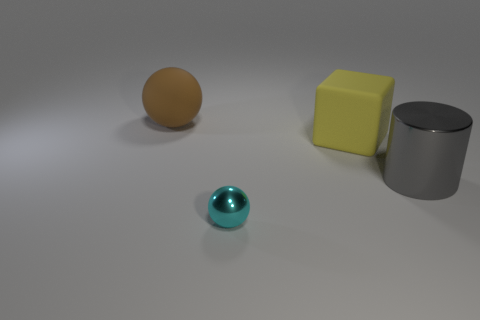Is there anything else that is the same shape as the gray thing?
Offer a terse response. No. Are there any other things that are the same size as the cyan shiny thing?
Your response must be concise. No. What number of things are either large matte objects that are in front of the brown object or things in front of the yellow matte object?
Ensure brevity in your answer.  3. What number of other objects are the same color as the metal ball?
Your response must be concise. 0. There is a shiny object left of the yellow matte cube; is its shape the same as the large yellow rubber object?
Ensure brevity in your answer.  No. Are there fewer balls that are behind the cyan shiny thing than green matte balls?
Offer a terse response. No. Are there any cylinders made of the same material as the small cyan sphere?
Give a very brief answer. Yes. There is a cylinder that is the same size as the yellow matte object; what is it made of?
Provide a short and direct response. Metal. Are there fewer large yellow blocks in front of the large metallic cylinder than objects behind the rubber cube?
Your answer should be very brief. Yes. There is a object that is both in front of the cube and on the right side of the small metallic sphere; what shape is it?
Your response must be concise. Cylinder. 